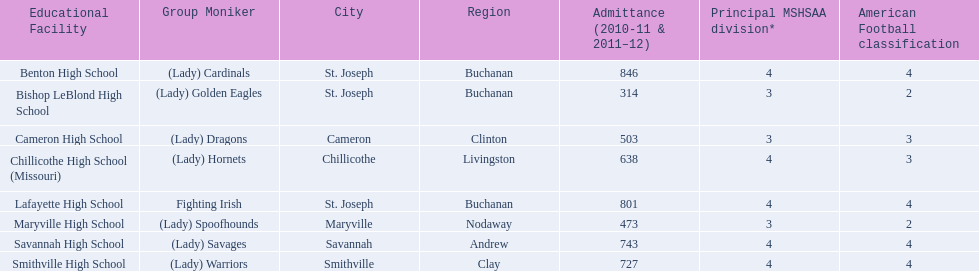What are all of the schools? Benton High School, Bishop LeBlond High School, Cameron High School, Chillicothe High School (Missouri), Lafayette High School, Maryville High School, Savannah High School, Smithville High School. How many football classes do they have? 4, 2, 3, 3, 4, 2, 4, 4. What about their enrollment? 846, 314, 503, 638, 801, 473, 743, 727. Which schools have 3 football classes? Cameron High School, Chillicothe High School (Missouri). And of those schools, which has 638 students? Chillicothe High School (Missouri). 